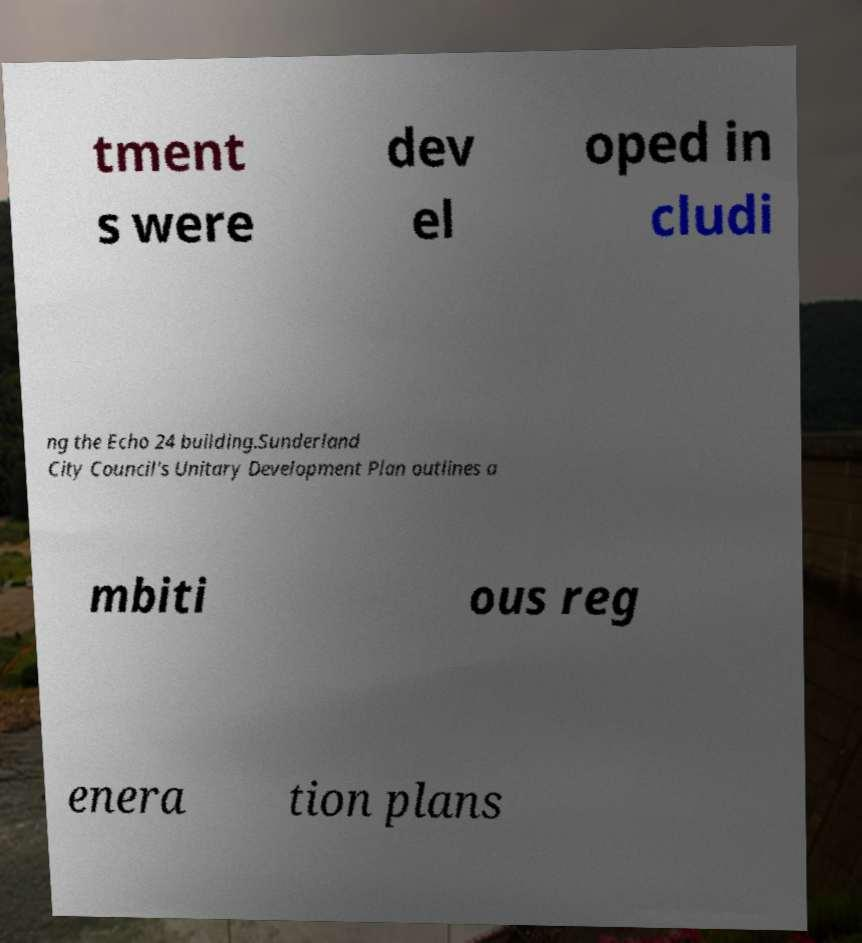Could you assist in decoding the text presented in this image and type it out clearly? tment s were dev el oped in cludi ng the Echo 24 building.Sunderland City Council's Unitary Development Plan outlines a mbiti ous reg enera tion plans 